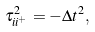<formula> <loc_0><loc_0><loc_500><loc_500>\tau _ { i i ^ { + } } ^ { 2 } = - \Delta t ^ { 2 } ,</formula> 